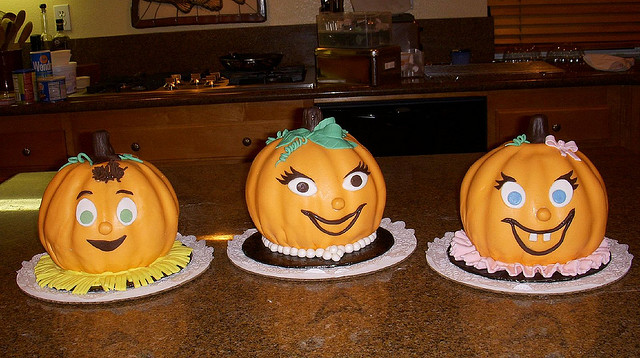What were these made for? These creatively decorated cakes were crafted for Halloween, featuring pumpkin shapes with cheerful and festive faces to delight guests during the spooky season celebrations. 